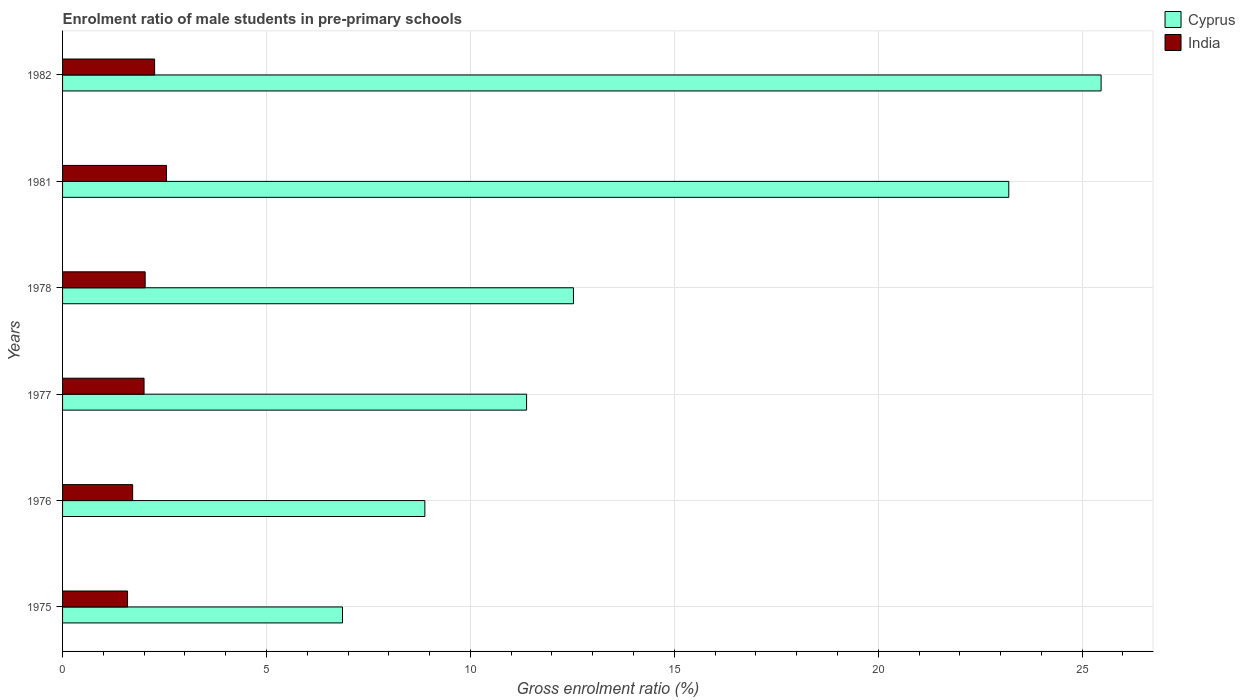How many different coloured bars are there?
Ensure brevity in your answer.  2. How many groups of bars are there?
Your answer should be very brief. 6. Are the number of bars per tick equal to the number of legend labels?
Provide a succinct answer. Yes. Are the number of bars on each tick of the Y-axis equal?
Keep it short and to the point. Yes. What is the label of the 2nd group of bars from the top?
Ensure brevity in your answer.  1981. In how many cases, is the number of bars for a given year not equal to the number of legend labels?
Offer a terse response. 0. What is the enrolment ratio of male students in pre-primary schools in Cyprus in 1981?
Provide a succinct answer. 23.2. Across all years, what is the maximum enrolment ratio of male students in pre-primary schools in India?
Ensure brevity in your answer.  2.55. Across all years, what is the minimum enrolment ratio of male students in pre-primary schools in India?
Ensure brevity in your answer.  1.59. In which year was the enrolment ratio of male students in pre-primary schools in India minimum?
Give a very brief answer. 1975. What is the total enrolment ratio of male students in pre-primary schools in Cyprus in the graph?
Keep it short and to the point. 88.31. What is the difference between the enrolment ratio of male students in pre-primary schools in India in 1976 and that in 1978?
Offer a terse response. -0.31. What is the difference between the enrolment ratio of male students in pre-primary schools in Cyprus in 1981 and the enrolment ratio of male students in pre-primary schools in India in 1978?
Keep it short and to the point. 21.17. What is the average enrolment ratio of male students in pre-primary schools in Cyprus per year?
Your response must be concise. 14.72. In the year 1976, what is the difference between the enrolment ratio of male students in pre-primary schools in India and enrolment ratio of male students in pre-primary schools in Cyprus?
Offer a very short reply. -7.16. What is the ratio of the enrolment ratio of male students in pre-primary schools in India in 1976 to that in 1981?
Your answer should be very brief. 0.67. Is the enrolment ratio of male students in pre-primary schools in India in 1977 less than that in 1982?
Give a very brief answer. Yes. Is the difference between the enrolment ratio of male students in pre-primary schools in India in 1981 and 1982 greater than the difference between the enrolment ratio of male students in pre-primary schools in Cyprus in 1981 and 1982?
Keep it short and to the point. Yes. What is the difference between the highest and the second highest enrolment ratio of male students in pre-primary schools in Cyprus?
Provide a short and direct response. 2.26. What is the difference between the highest and the lowest enrolment ratio of male students in pre-primary schools in India?
Give a very brief answer. 0.95. In how many years, is the enrolment ratio of male students in pre-primary schools in Cyprus greater than the average enrolment ratio of male students in pre-primary schools in Cyprus taken over all years?
Make the answer very short. 2. Is the sum of the enrolment ratio of male students in pre-primary schools in Cyprus in 1976 and 1981 greater than the maximum enrolment ratio of male students in pre-primary schools in India across all years?
Offer a terse response. Yes. How many bars are there?
Your answer should be very brief. 12. What is the title of the graph?
Offer a very short reply. Enrolment ratio of male students in pre-primary schools. Does "Korea (Democratic)" appear as one of the legend labels in the graph?
Give a very brief answer. No. What is the label or title of the Y-axis?
Your answer should be compact. Years. What is the Gross enrolment ratio (%) of Cyprus in 1975?
Ensure brevity in your answer.  6.86. What is the Gross enrolment ratio (%) in India in 1975?
Offer a very short reply. 1.59. What is the Gross enrolment ratio (%) in Cyprus in 1976?
Give a very brief answer. 8.88. What is the Gross enrolment ratio (%) of India in 1976?
Your response must be concise. 1.72. What is the Gross enrolment ratio (%) in Cyprus in 1977?
Provide a short and direct response. 11.38. What is the Gross enrolment ratio (%) in India in 1977?
Provide a succinct answer. 2. What is the Gross enrolment ratio (%) of Cyprus in 1978?
Your response must be concise. 12.53. What is the Gross enrolment ratio (%) of India in 1978?
Provide a short and direct response. 2.03. What is the Gross enrolment ratio (%) in Cyprus in 1981?
Offer a terse response. 23.2. What is the Gross enrolment ratio (%) of India in 1981?
Ensure brevity in your answer.  2.55. What is the Gross enrolment ratio (%) in Cyprus in 1982?
Give a very brief answer. 25.46. What is the Gross enrolment ratio (%) in India in 1982?
Your response must be concise. 2.26. Across all years, what is the maximum Gross enrolment ratio (%) in Cyprus?
Provide a succinct answer. 25.46. Across all years, what is the maximum Gross enrolment ratio (%) of India?
Provide a succinct answer. 2.55. Across all years, what is the minimum Gross enrolment ratio (%) in Cyprus?
Provide a succinct answer. 6.86. Across all years, what is the minimum Gross enrolment ratio (%) in India?
Your answer should be very brief. 1.59. What is the total Gross enrolment ratio (%) in Cyprus in the graph?
Keep it short and to the point. 88.31. What is the total Gross enrolment ratio (%) of India in the graph?
Offer a terse response. 12.14. What is the difference between the Gross enrolment ratio (%) in Cyprus in 1975 and that in 1976?
Your response must be concise. -2.02. What is the difference between the Gross enrolment ratio (%) of India in 1975 and that in 1976?
Keep it short and to the point. -0.12. What is the difference between the Gross enrolment ratio (%) in Cyprus in 1975 and that in 1977?
Give a very brief answer. -4.51. What is the difference between the Gross enrolment ratio (%) in India in 1975 and that in 1977?
Make the answer very short. -0.4. What is the difference between the Gross enrolment ratio (%) of Cyprus in 1975 and that in 1978?
Your response must be concise. -5.66. What is the difference between the Gross enrolment ratio (%) of India in 1975 and that in 1978?
Your answer should be compact. -0.43. What is the difference between the Gross enrolment ratio (%) of Cyprus in 1975 and that in 1981?
Provide a short and direct response. -16.34. What is the difference between the Gross enrolment ratio (%) of India in 1975 and that in 1981?
Your response must be concise. -0.95. What is the difference between the Gross enrolment ratio (%) of Cyprus in 1975 and that in 1982?
Your answer should be very brief. -18.6. What is the difference between the Gross enrolment ratio (%) of India in 1975 and that in 1982?
Provide a short and direct response. -0.66. What is the difference between the Gross enrolment ratio (%) of Cyprus in 1976 and that in 1977?
Offer a terse response. -2.49. What is the difference between the Gross enrolment ratio (%) of India in 1976 and that in 1977?
Provide a short and direct response. -0.28. What is the difference between the Gross enrolment ratio (%) in Cyprus in 1976 and that in 1978?
Keep it short and to the point. -3.64. What is the difference between the Gross enrolment ratio (%) of India in 1976 and that in 1978?
Your response must be concise. -0.31. What is the difference between the Gross enrolment ratio (%) in Cyprus in 1976 and that in 1981?
Keep it short and to the point. -14.32. What is the difference between the Gross enrolment ratio (%) of India in 1976 and that in 1981?
Your answer should be very brief. -0.83. What is the difference between the Gross enrolment ratio (%) of Cyprus in 1976 and that in 1982?
Offer a terse response. -16.58. What is the difference between the Gross enrolment ratio (%) of India in 1976 and that in 1982?
Ensure brevity in your answer.  -0.54. What is the difference between the Gross enrolment ratio (%) of Cyprus in 1977 and that in 1978?
Your response must be concise. -1.15. What is the difference between the Gross enrolment ratio (%) of India in 1977 and that in 1978?
Give a very brief answer. -0.03. What is the difference between the Gross enrolment ratio (%) of Cyprus in 1977 and that in 1981?
Ensure brevity in your answer.  -11.82. What is the difference between the Gross enrolment ratio (%) of India in 1977 and that in 1981?
Provide a succinct answer. -0.55. What is the difference between the Gross enrolment ratio (%) of Cyprus in 1977 and that in 1982?
Ensure brevity in your answer.  -14.09. What is the difference between the Gross enrolment ratio (%) of India in 1977 and that in 1982?
Offer a very short reply. -0.26. What is the difference between the Gross enrolment ratio (%) of Cyprus in 1978 and that in 1981?
Offer a terse response. -10.67. What is the difference between the Gross enrolment ratio (%) of India in 1978 and that in 1981?
Keep it short and to the point. -0.52. What is the difference between the Gross enrolment ratio (%) in Cyprus in 1978 and that in 1982?
Your response must be concise. -12.94. What is the difference between the Gross enrolment ratio (%) of India in 1978 and that in 1982?
Offer a terse response. -0.23. What is the difference between the Gross enrolment ratio (%) in Cyprus in 1981 and that in 1982?
Provide a succinct answer. -2.26. What is the difference between the Gross enrolment ratio (%) in India in 1981 and that in 1982?
Make the answer very short. 0.29. What is the difference between the Gross enrolment ratio (%) in Cyprus in 1975 and the Gross enrolment ratio (%) in India in 1976?
Ensure brevity in your answer.  5.14. What is the difference between the Gross enrolment ratio (%) in Cyprus in 1975 and the Gross enrolment ratio (%) in India in 1977?
Your response must be concise. 4.87. What is the difference between the Gross enrolment ratio (%) of Cyprus in 1975 and the Gross enrolment ratio (%) of India in 1978?
Ensure brevity in your answer.  4.84. What is the difference between the Gross enrolment ratio (%) in Cyprus in 1975 and the Gross enrolment ratio (%) in India in 1981?
Give a very brief answer. 4.31. What is the difference between the Gross enrolment ratio (%) of Cyprus in 1975 and the Gross enrolment ratio (%) of India in 1982?
Keep it short and to the point. 4.61. What is the difference between the Gross enrolment ratio (%) of Cyprus in 1976 and the Gross enrolment ratio (%) of India in 1977?
Ensure brevity in your answer.  6.88. What is the difference between the Gross enrolment ratio (%) of Cyprus in 1976 and the Gross enrolment ratio (%) of India in 1978?
Provide a short and direct response. 6.86. What is the difference between the Gross enrolment ratio (%) in Cyprus in 1976 and the Gross enrolment ratio (%) in India in 1981?
Keep it short and to the point. 6.33. What is the difference between the Gross enrolment ratio (%) of Cyprus in 1976 and the Gross enrolment ratio (%) of India in 1982?
Your answer should be very brief. 6.63. What is the difference between the Gross enrolment ratio (%) of Cyprus in 1977 and the Gross enrolment ratio (%) of India in 1978?
Give a very brief answer. 9.35. What is the difference between the Gross enrolment ratio (%) of Cyprus in 1977 and the Gross enrolment ratio (%) of India in 1981?
Make the answer very short. 8.83. What is the difference between the Gross enrolment ratio (%) in Cyprus in 1977 and the Gross enrolment ratio (%) in India in 1982?
Provide a short and direct response. 9.12. What is the difference between the Gross enrolment ratio (%) in Cyprus in 1978 and the Gross enrolment ratio (%) in India in 1981?
Your response must be concise. 9.98. What is the difference between the Gross enrolment ratio (%) in Cyprus in 1978 and the Gross enrolment ratio (%) in India in 1982?
Keep it short and to the point. 10.27. What is the difference between the Gross enrolment ratio (%) in Cyprus in 1981 and the Gross enrolment ratio (%) in India in 1982?
Offer a terse response. 20.94. What is the average Gross enrolment ratio (%) in Cyprus per year?
Offer a very short reply. 14.72. What is the average Gross enrolment ratio (%) in India per year?
Make the answer very short. 2.02. In the year 1975, what is the difference between the Gross enrolment ratio (%) in Cyprus and Gross enrolment ratio (%) in India?
Offer a very short reply. 5.27. In the year 1976, what is the difference between the Gross enrolment ratio (%) of Cyprus and Gross enrolment ratio (%) of India?
Offer a terse response. 7.16. In the year 1977, what is the difference between the Gross enrolment ratio (%) of Cyprus and Gross enrolment ratio (%) of India?
Keep it short and to the point. 9.38. In the year 1978, what is the difference between the Gross enrolment ratio (%) of Cyprus and Gross enrolment ratio (%) of India?
Offer a terse response. 10.5. In the year 1981, what is the difference between the Gross enrolment ratio (%) in Cyprus and Gross enrolment ratio (%) in India?
Offer a terse response. 20.65. In the year 1982, what is the difference between the Gross enrolment ratio (%) in Cyprus and Gross enrolment ratio (%) in India?
Ensure brevity in your answer.  23.21. What is the ratio of the Gross enrolment ratio (%) in Cyprus in 1975 to that in 1976?
Keep it short and to the point. 0.77. What is the ratio of the Gross enrolment ratio (%) of India in 1975 to that in 1976?
Provide a short and direct response. 0.93. What is the ratio of the Gross enrolment ratio (%) of Cyprus in 1975 to that in 1977?
Your response must be concise. 0.6. What is the ratio of the Gross enrolment ratio (%) of India in 1975 to that in 1977?
Keep it short and to the point. 0.8. What is the ratio of the Gross enrolment ratio (%) in Cyprus in 1975 to that in 1978?
Provide a succinct answer. 0.55. What is the ratio of the Gross enrolment ratio (%) of India in 1975 to that in 1978?
Provide a short and direct response. 0.79. What is the ratio of the Gross enrolment ratio (%) of Cyprus in 1975 to that in 1981?
Your response must be concise. 0.3. What is the ratio of the Gross enrolment ratio (%) of India in 1975 to that in 1981?
Give a very brief answer. 0.63. What is the ratio of the Gross enrolment ratio (%) in Cyprus in 1975 to that in 1982?
Provide a succinct answer. 0.27. What is the ratio of the Gross enrolment ratio (%) in India in 1975 to that in 1982?
Your answer should be compact. 0.71. What is the ratio of the Gross enrolment ratio (%) in Cyprus in 1976 to that in 1977?
Your answer should be very brief. 0.78. What is the ratio of the Gross enrolment ratio (%) in India in 1976 to that in 1977?
Give a very brief answer. 0.86. What is the ratio of the Gross enrolment ratio (%) of Cyprus in 1976 to that in 1978?
Keep it short and to the point. 0.71. What is the ratio of the Gross enrolment ratio (%) of India in 1976 to that in 1978?
Provide a short and direct response. 0.85. What is the ratio of the Gross enrolment ratio (%) in Cyprus in 1976 to that in 1981?
Your answer should be very brief. 0.38. What is the ratio of the Gross enrolment ratio (%) in India in 1976 to that in 1981?
Your response must be concise. 0.67. What is the ratio of the Gross enrolment ratio (%) of Cyprus in 1976 to that in 1982?
Provide a succinct answer. 0.35. What is the ratio of the Gross enrolment ratio (%) of India in 1976 to that in 1982?
Provide a succinct answer. 0.76. What is the ratio of the Gross enrolment ratio (%) of Cyprus in 1977 to that in 1978?
Keep it short and to the point. 0.91. What is the ratio of the Gross enrolment ratio (%) in India in 1977 to that in 1978?
Provide a short and direct response. 0.99. What is the ratio of the Gross enrolment ratio (%) of Cyprus in 1977 to that in 1981?
Your answer should be compact. 0.49. What is the ratio of the Gross enrolment ratio (%) of India in 1977 to that in 1981?
Offer a terse response. 0.78. What is the ratio of the Gross enrolment ratio (%) of Cyprus in 1977 to that in 1982?
Provide a succinct answer. 0.45. What is the ratio of the Gross enrolment ratio (%) in India in 1977 to that in 1982?
Keep it short and to the point. 0.89. What is the ratio of the Gross enrolment ratio (%) of Cyprus in 1978 to that in 1981?
Your answer should be very brief. 0.54. What is the ratio of the Gross enrolment ratio (%) in India in 1978 to that in 1981?
Your answer should be compact. 0.79. What is the ratio of the Gross enrolment ratio (%) in Cyprus in 1978 to that in 1982?
Your answer should be compact. 0.49. What is the ratio of the Gross enrolment ratio (%) in India in 1978 to that in 1982?
Your answer should be compact. 0.9. What is the ratio of the Gross enrolment ratio (%) of Cyprus in 1981 to that in 1982?
Your response must be concise. 0.91. What is the ratio of the Gross enrolment ratio (%) of India in 1981 to that in 1982?
Your response must be concise. 1.13. What is the difference between the highest and the second highest Gross enrolment ratio (%) in Cyprus?
Ensure brevity in your answer.  2.26. What is the difference between the highest and the second highest Gross enrolment ratio (%) in India?
Offer a terse response. 0.29. What is the difference between the highest and the lowest Gross enrolment ratio (%) of Cyprus?
Your answer should be compact. 18.6. What is the difference between the highest and the lowest Gross enrolment ratio (%) of India?
Your response must be concise. 0.95. 